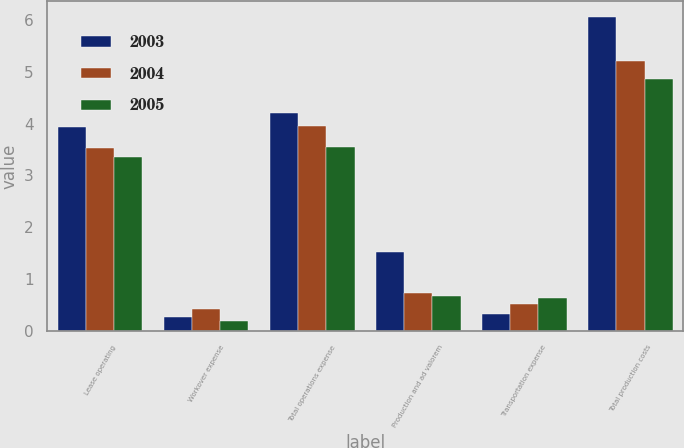<chart> <loc_0><loc_0><loc_500><loc_500><stacked_bar_chart><ecel><fcel>Lease operating<fcel>Workover expense<fcel>Total operations expense<fcel>Production and ad valorem<fcel>Transportation expense<fcel>Total production costs<nl><fcel>2003<fcel>3.94<fcel>0.27<fcel>4.21<fcel>1.52<fcel>0.33<fcel>6.06<nl><fcel>2004<fcel>3.53<fcel>0.43<fcel>3.96<fcel>0.73<fcel>0.51<fcel>5.2<nl><fcel>2005<fcel>3.36<fcel>0.19<fcel>3.55<fcel>0.68<fcel>0.63<fcel>4.86<nl></chart> 